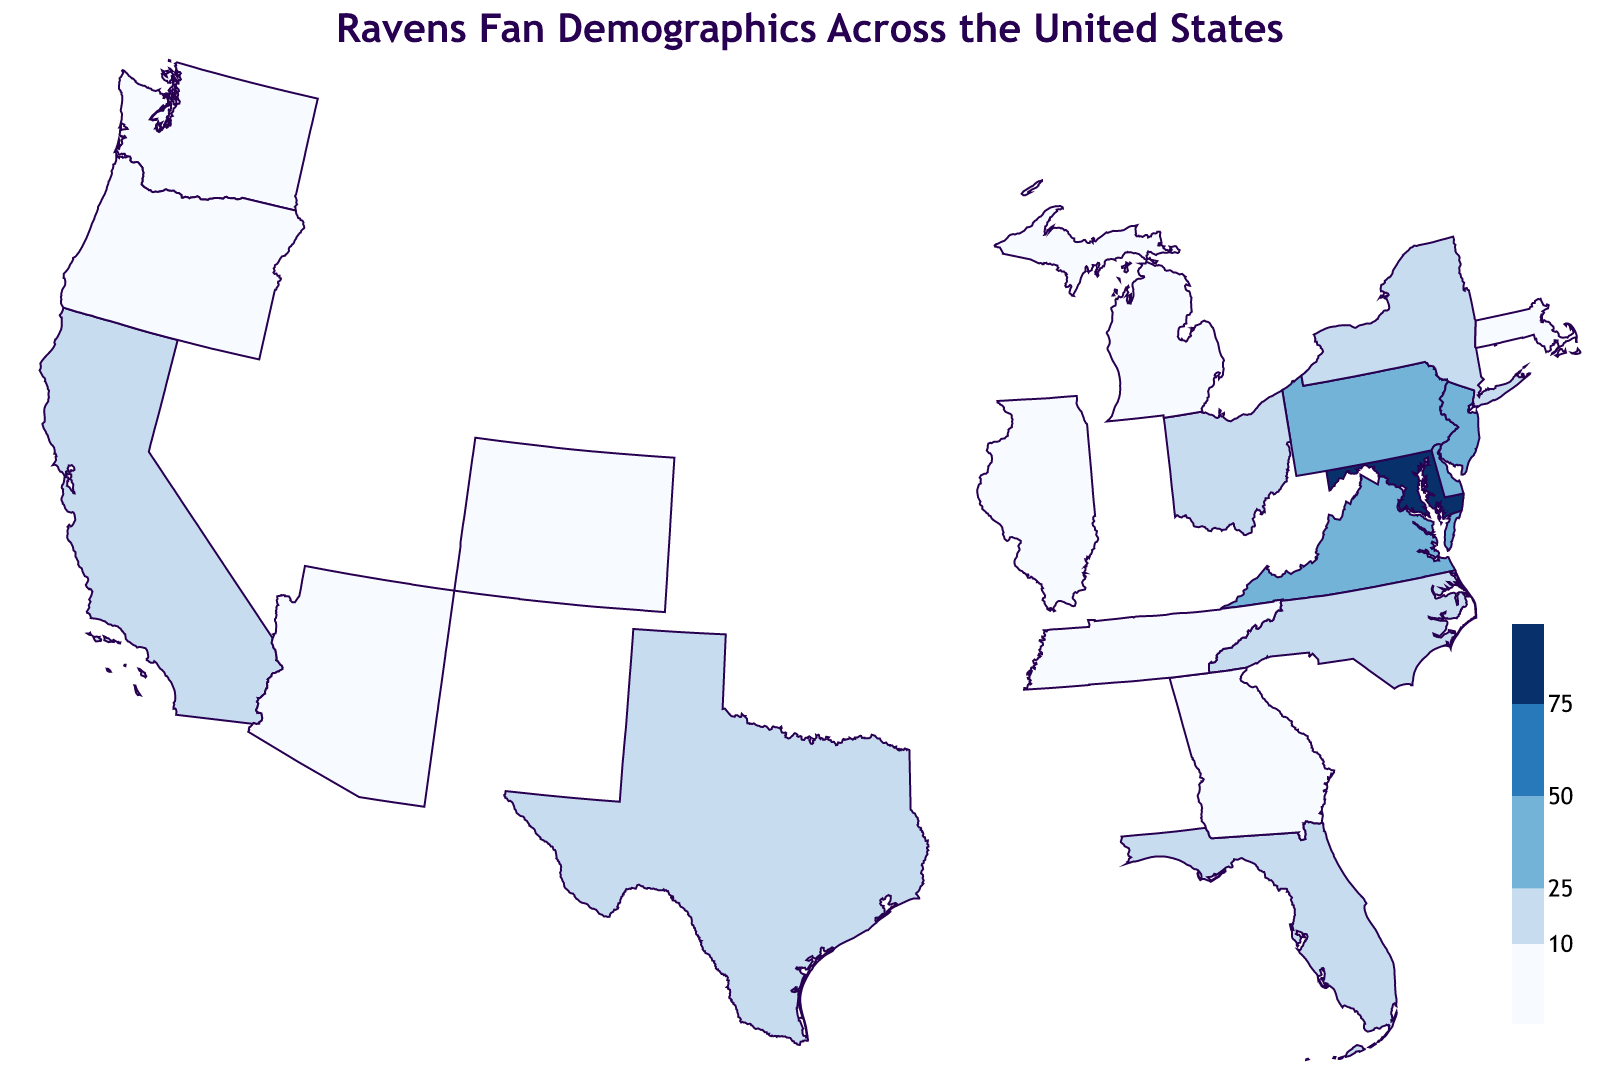What is the title of the figure? The title of the figure can be located at the top of the visualization, written plainly in a larger and bold font. This makes it clear and eye-catching for observers.
Answer: Ravens Fan Demographics Across the United States Which state has the highest percentage of Ravens fans? By looking at the color gradient representation and the numerical value within the tooltip for each state, we can see that Maryland has the deepest color, indicating the highest percentage.
Answer: Maryland How many states have a Ravens fan percentage below 10%? Assess the states that have the lightest color shade, which represents percentages below 10%, and count them. The states are Texas, Massachusetts, Illinois, Georgia, Washington, Colorado, Arizona, Oregon, Michigan, and Tennessee. There are 10 such states.
Answer: 10 What is the difference in the percentage of Ravens fans between Pennsylvania and Delaware? By comparing the tooltip values for Pennsylvania (42%) and Delaware (35%), we subtract to find the difference: 42 - 35 = 7.
Answer: 7 Which state has a similar percentage of Ravens fans as North Carolina? By examining the map, we compare the color gradient and tooltip values. Ohio, with a percentage of 18%, is closely similar to North Carolina's 20%.
Answer: Ohio Is the percentage of Ravens fans in California higher or lower than in Texas? By referring to both states on the map and comparing the numerical values in their tooltips, we see California has 12% and Texas has 10%. Hence, California has a higher percentage.
Answer: Higher What can you infer about the regional distribution of Ravens fans based on the visual representation? Observing the color patterns, we notice that the darkest shades congregate around Maryland and nearby states in the Mid-Atlantic region, indicating higher percentages. Conversely, lighter shades dominate further away, suggesting lower concentrations. This indicates a strong regional following around Maryland with decreasing intensity moving away.
Answer: Strong regional following around Maryland Which regions (East, West, North, South) appear to have the least concentration of Ravens fans? By examining the general lightness and distribution of the color shading across the map, the western (California, Oregon, Washington, Arizona) and southern regions (Texas, Georgia) show lighter shades, indicating lower concentrations of Ravens fans.
Answer: West and South 